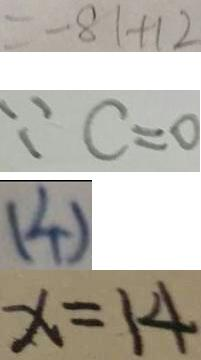<formula> <loc_0><loc_0><loc_500><loc_500>= - 8 1 + 1 2 
 \because c = 0 
 ( 4 ) 
 x = 1 4</formula> 